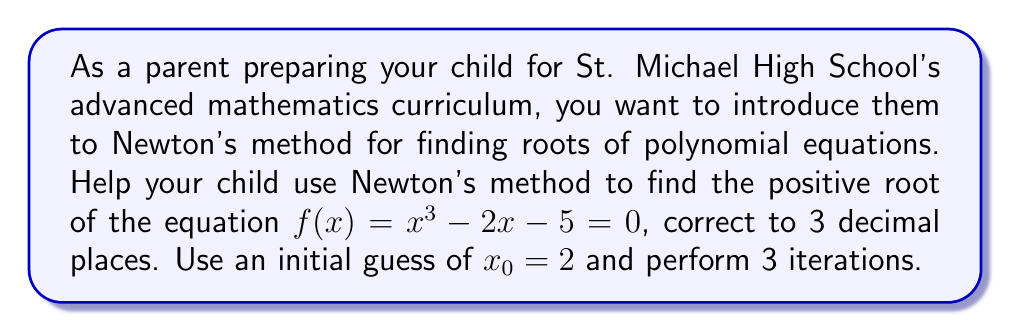Can you answer this question? Let's walk through this problem step-by-step using Newton's method:

1) Newton's method formula: $x_{n+1} = x_n - \frac{f(x_n)}{f'(x_n)}$

2) For our function $f(x) = x^3 - 2x - 5$, we need to find $f'(x)$:
   $f'(x) = 3x^2 - 2$

3) Now, let's perform the iterations:

   Iteration 1:
   $x_1 = x_0 - \frac{f(x_0)}{f'(x_0)}$
   $x_1 = 2 - \frac{2^3 - 2(2) - 5}{3(2)^2 - 2}$
   $x_1 = 2 - \frac{8 - 4 - 5}{12 - 2} = 2 - \frac{-1}{10} = 2.1$

   Iteration 2:
   $x_2 = 2.1 - \frac{(2.1)^3 - 2(2.1) - 5}{3(2.1)^2 - 2}$
   $x_2 = 2.1 - \frac{9.261 - 4.2 - 5}{13.23 - 2} = 2.1 - \frac{0.061}{11.23} \approx 2.094568$

   Iteration 3:
   $x_3 = 2.094568 - \frac{(2.094568)^3 - 2(2.094568) - 5}{3(2.094568)^2 - 2}$
   $x_3 \approx 2.094551$

4) Rounding to 3 decimal places, we get 2.095.
Answer: 2.095 